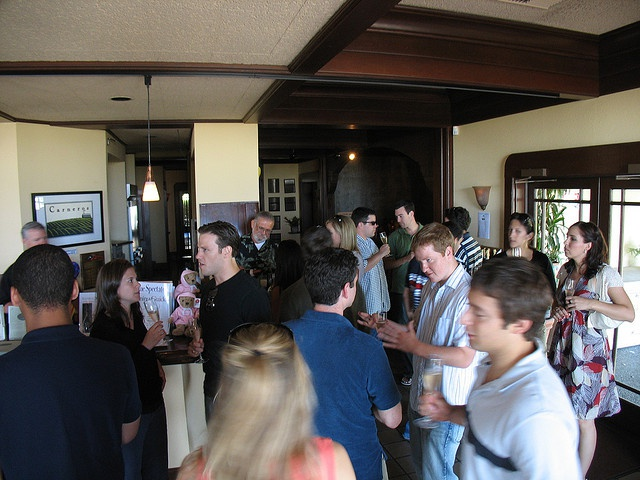Describe the objects in this image and their specific colors. I can see people in gray, black, brown, and maroon tones, people in gray, white, darkgray, and black tones, people in gray, darkblue, black, and blue tones, people in gray and darkgray tones, and people in gray, lavender, and black tones in this image. 